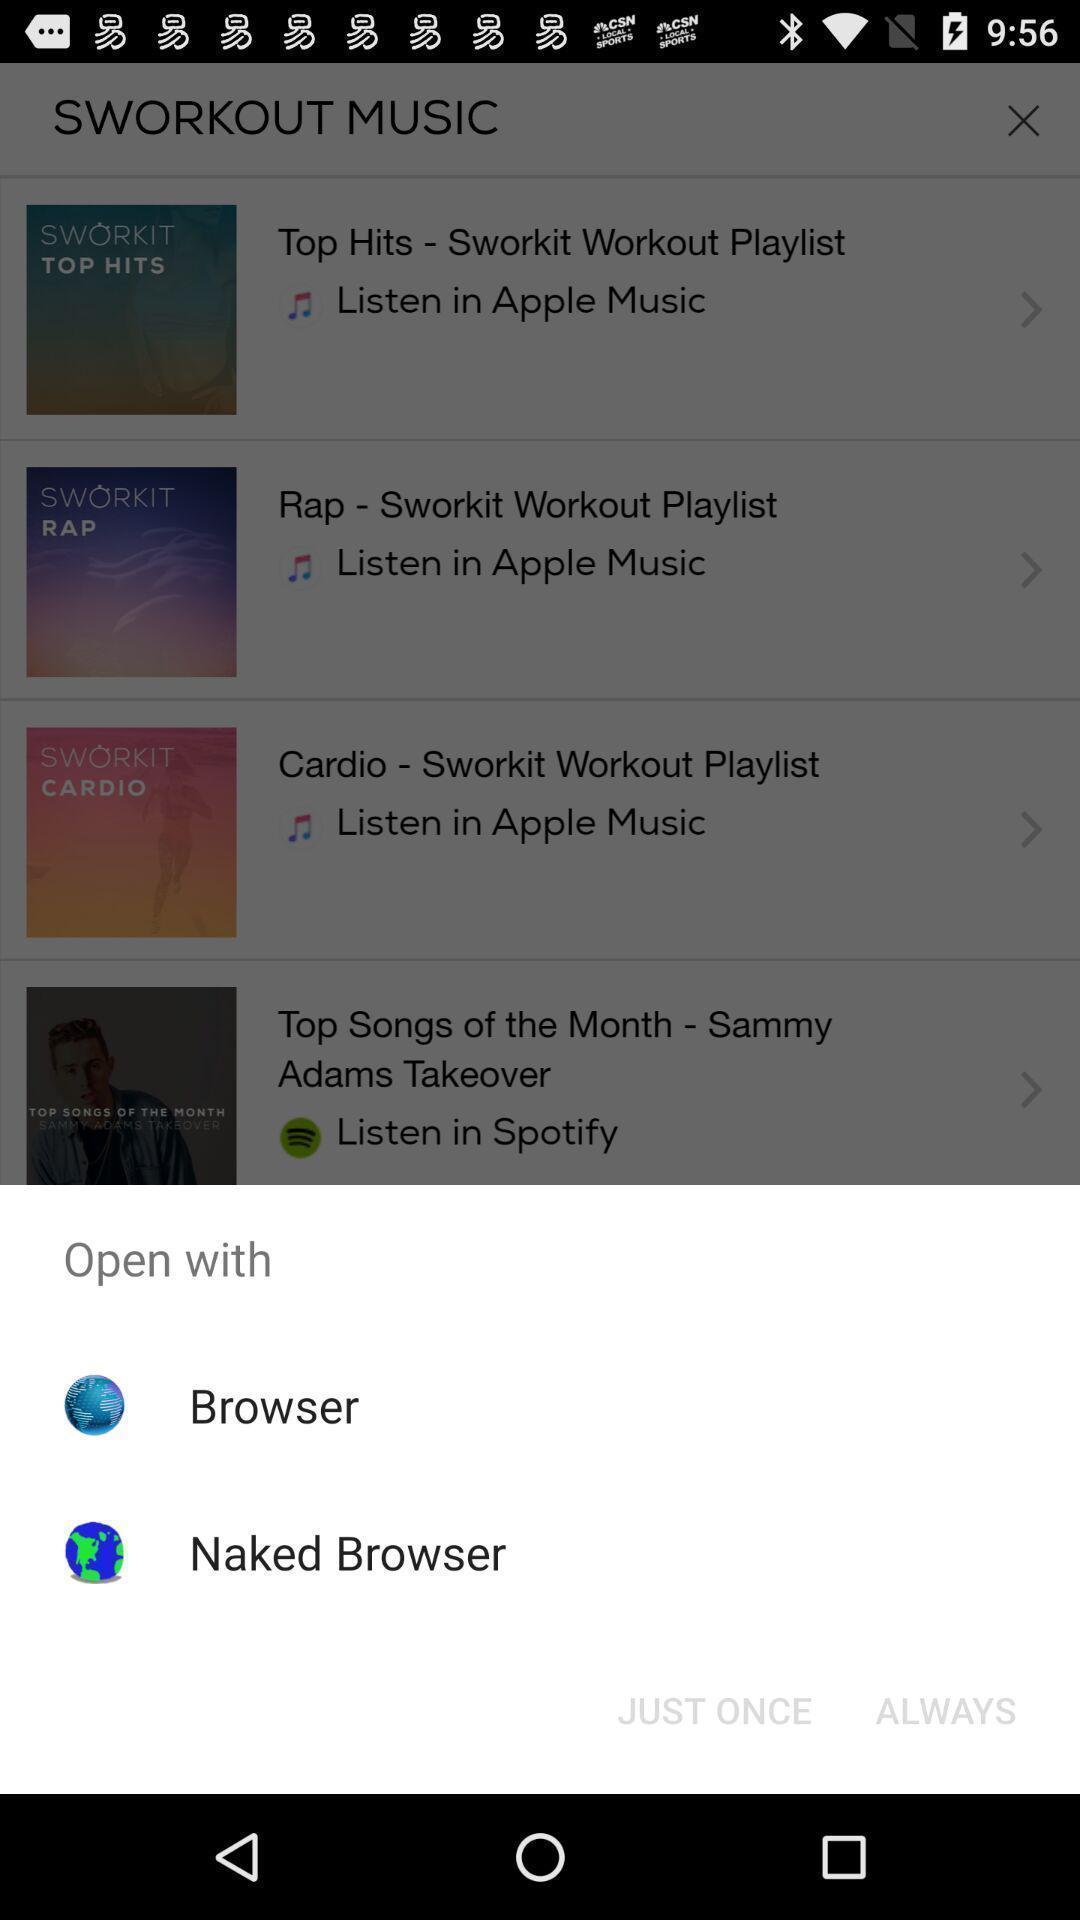Summarize the main components in this picture. Pop-up showing the options to open a browser. 